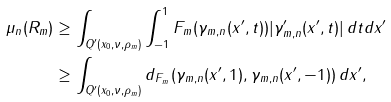Convert formula to latex. <formula><loc_0><loc_0><loc_500><loc_500>\mu _ { n } ( R _ { m } ) & \geq \int _ { Q ^ { \prime } ( x _ { 0 } , \nu , \rho _ { m } ) } \int _ { - 1 } ^ { 1 } F _ { m } ( \gamma _ { m , n } ( x ^ { \prime } , t ) ) | \gamma ^ { \prime } _ { m , n } ( x ^ { \prime } , t ) | \, d t d x ^ { \prime } \\ & \geq \int _ { Q ^ { \prime } ( x _ { 0 } , \nu , \rho _ { m } ) } d _ { F _ { m } } ( \gamma _ { m , n } ( x ^ { \prime } , 1 ) , \gamma _ { m , n } ( x ^ { \prime } , - 1 ) ) \, d x ^ { \prime } ,</formula> 